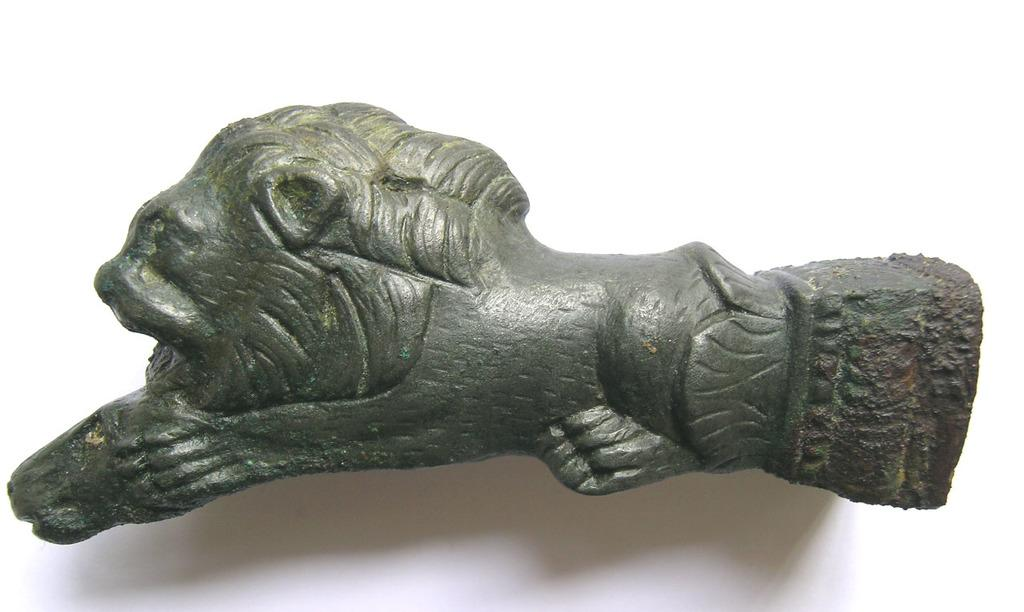What is the main subject of the image? There is a sculpture in the image. What can be seen in the background of the image? The background of the image is white. What is the purpose of the destruction depicted in the sculpture? There is no destruction depicted in the sculpture or the image; it is a sculpture on a white background. What type of battle is taking place in the image? There is no battle depicted in the image; it is a sculpture on a white background. 